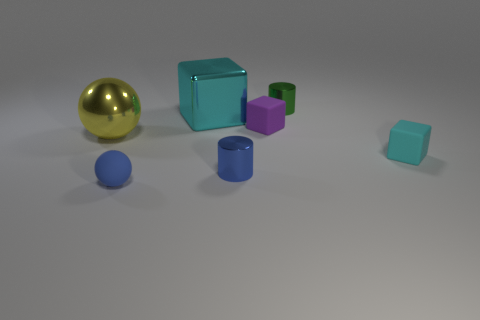Are there fewer big cyan metal cubes that are to the right of the cyan shiny cube than red cubes?
Your answer should be very brief. No. Does the small cylinder right of the small purple matte object have the same color as the large block?
Give a very brief answer. No. What number of shiny objects are either green things or large objects?
Ensure brevity in your answer.  3. Is there any other thing that is the same size as the metal ball?
Your response must be concise. Yes. There is a big ball that is made of the same material as the large block; what is its color?
Provide a succinct answer. Yellow. How many cylinders are purple matte objects or yellow metal objects?
Make the answer very short. 0. What number of objects are big red objects or rubber objects that are to the right of the blue matte thing?
Offer a terse response. 2. Are any metal cylinders visible?
Offer a terse response. Yes. What number of tiny rubber things have the same color as the big shiny block?
Give a very brief answer. 1. What is the material of the tiny cube that is the same color as the large block?
Make the answer very short. Rubber. 